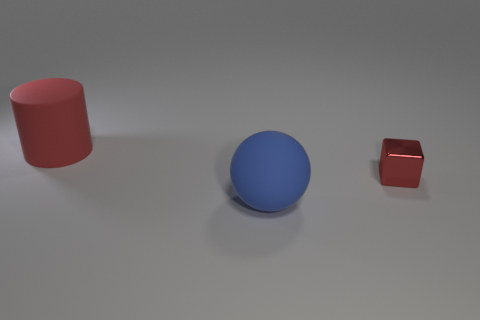There is a red object that is behind the small red thing; is its size the same as the red shiny thing behind the blue matte sphere?
Your answer should be compact. No. Is the number of large red matte things that are in front of the big sphere greater than the number of red matte cylinders to the right of the big red matte cylinder?
Offer a terse response. No. There is another object that is the same size as the red matte thing; what is its material?
Your answer should be very brief. Rubber. Is there a large red cylinder that has the same material as the small red block?
Keep it short and to the point. No. Is the number of small red objects that are behind the big red rubber thing less than the number of tiny red cubes?
Your answer should be compact. Yes. The big object that is left of the object that is in front of the red metal block is made of what material?
Your response must be concise. Rubber. What shape is the thing that is both in front of the red rubber cylinder and to the left of the block?
Ensure brevity in your answer.  Sphere. What number of other things are there of the same color as the sphere?
Your answer should be very brief. 0. How many objects are either red things that are to the right of the cylinder or big cyan matte balls?
Give a very brief answer. 1. Does the cylinder have the same color as the large thing in front of the small thing?
Keep it short and to the point. No. 